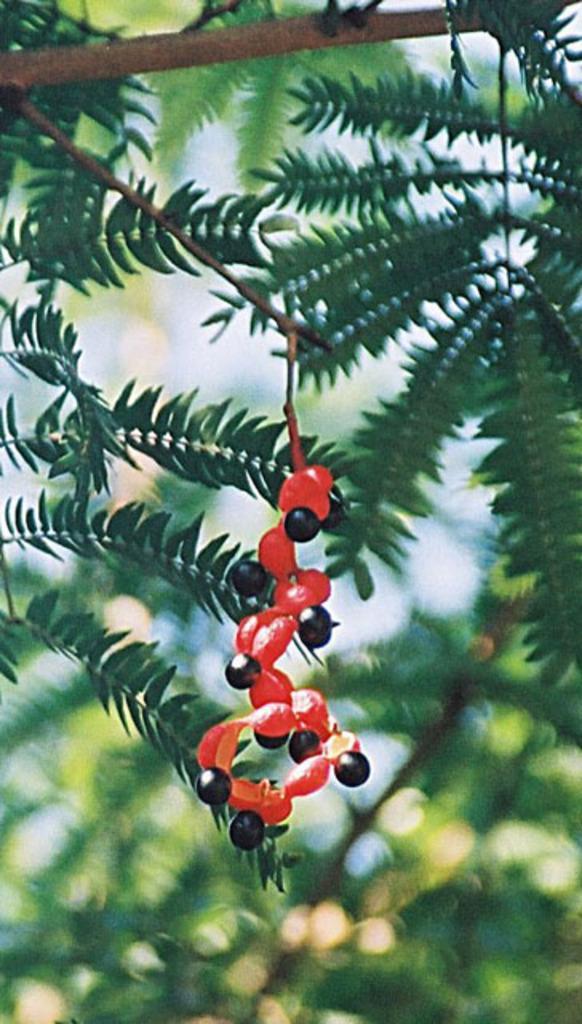How would you summarize this image in a sentence or two? In this image there is a tree branch, on which there is an object, behind the tree may be there is the sky. 